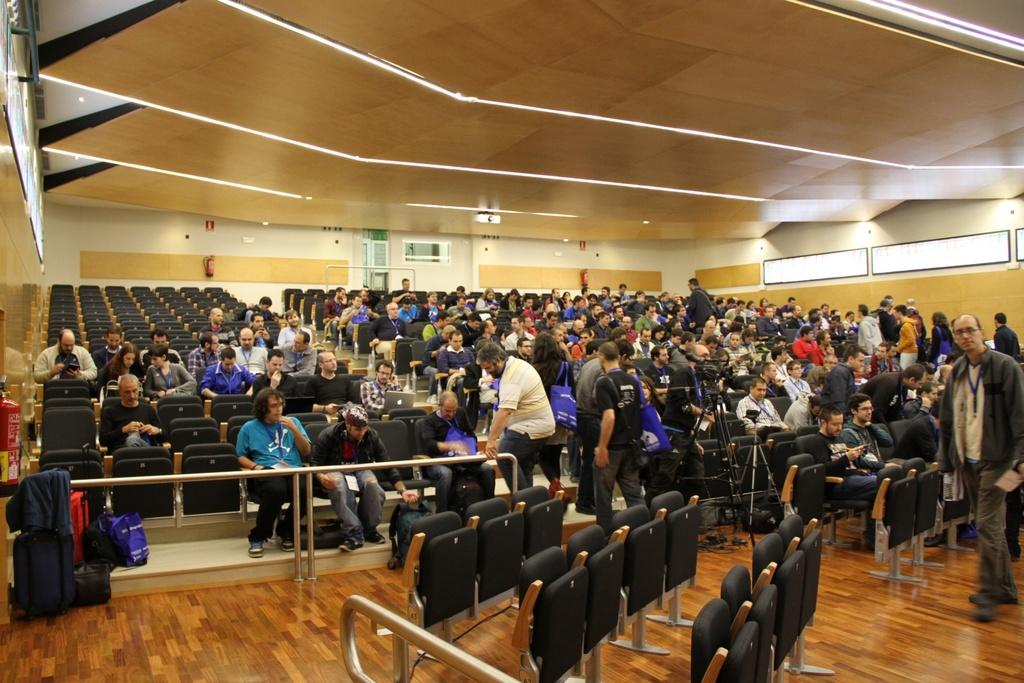What is the primary activity of the people in the image? The people in the image are sitting, which suggests they might be attending an event or gathering. What type of location is depicted in the image? The setting appears to be a conference hall, based on the presence of many chairs and the arrangement of the people. What architectural features are visible in the image? There is a roof and a floor visible in the image, which indicates that it is an enclosed space. How many horses can be seen grazing on the floor in the image? There are no horses present in the image; it depicts a conference hall with many people sitting in chairs. 